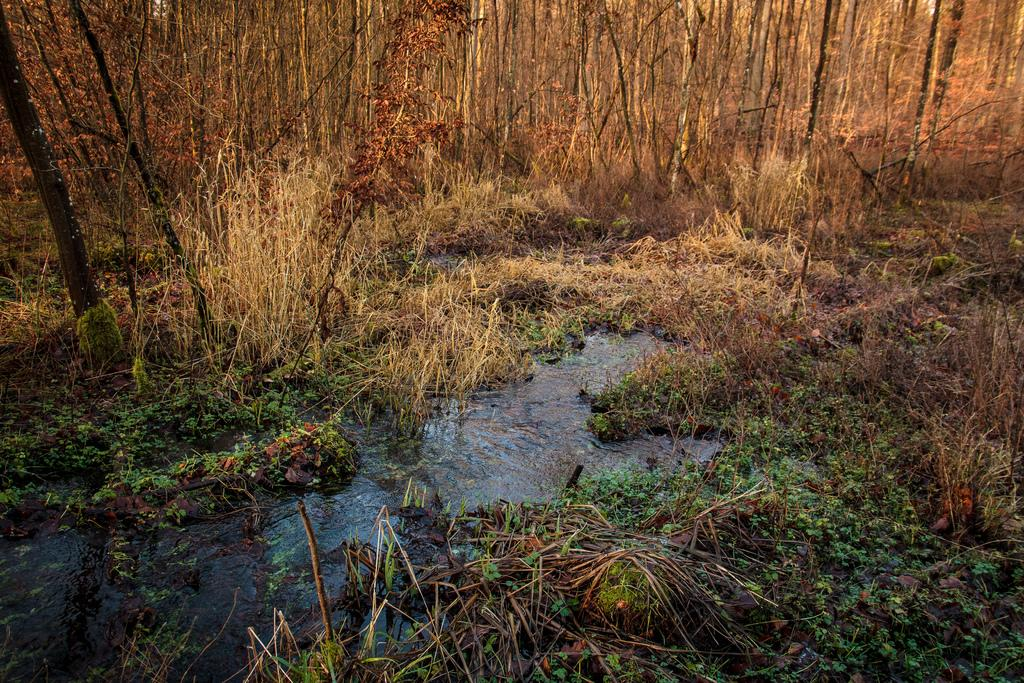What type of vegetation can be seen in the image? There is dry grass and grass visible in the image. What else can be seen in the image besides vegetation? There is water and trees visible in the image. Can you see a pipe being used by a squirrel in the image? There is no pipe or squirrel present in the image. What type of bun is being held by the tree in the image? There is no bun present in the image; it only features dry grass, grass, water, and trees. 